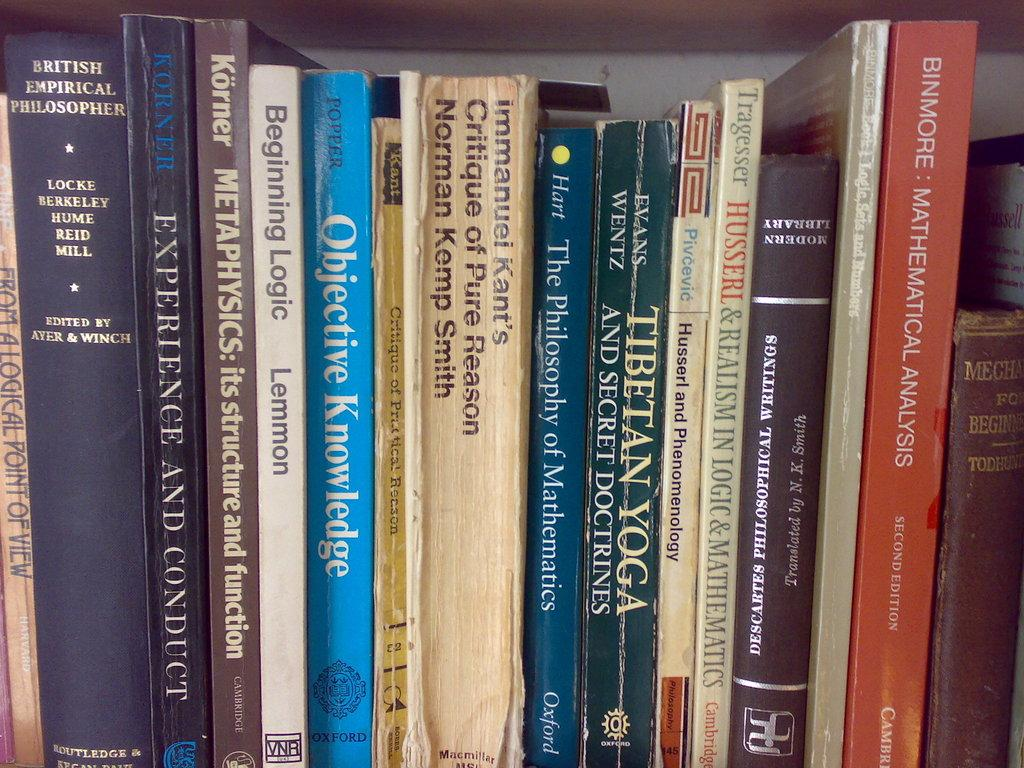<image>
Provide a brief description of the given image. The book about logic is in between the books about metaphysics and knowledge. 